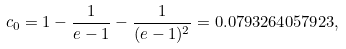<formula> <loc_0><loc_0><loc_500><loc_500>c _ { 0 } = 1 - \frac { 1 } { e - 1 } - \frac { 1 } { ( e - 1 ) ^ { 2 } } = 0 . 0 7 9 3 2 6 4 0 5 7 9 2 3 ,</formula> 